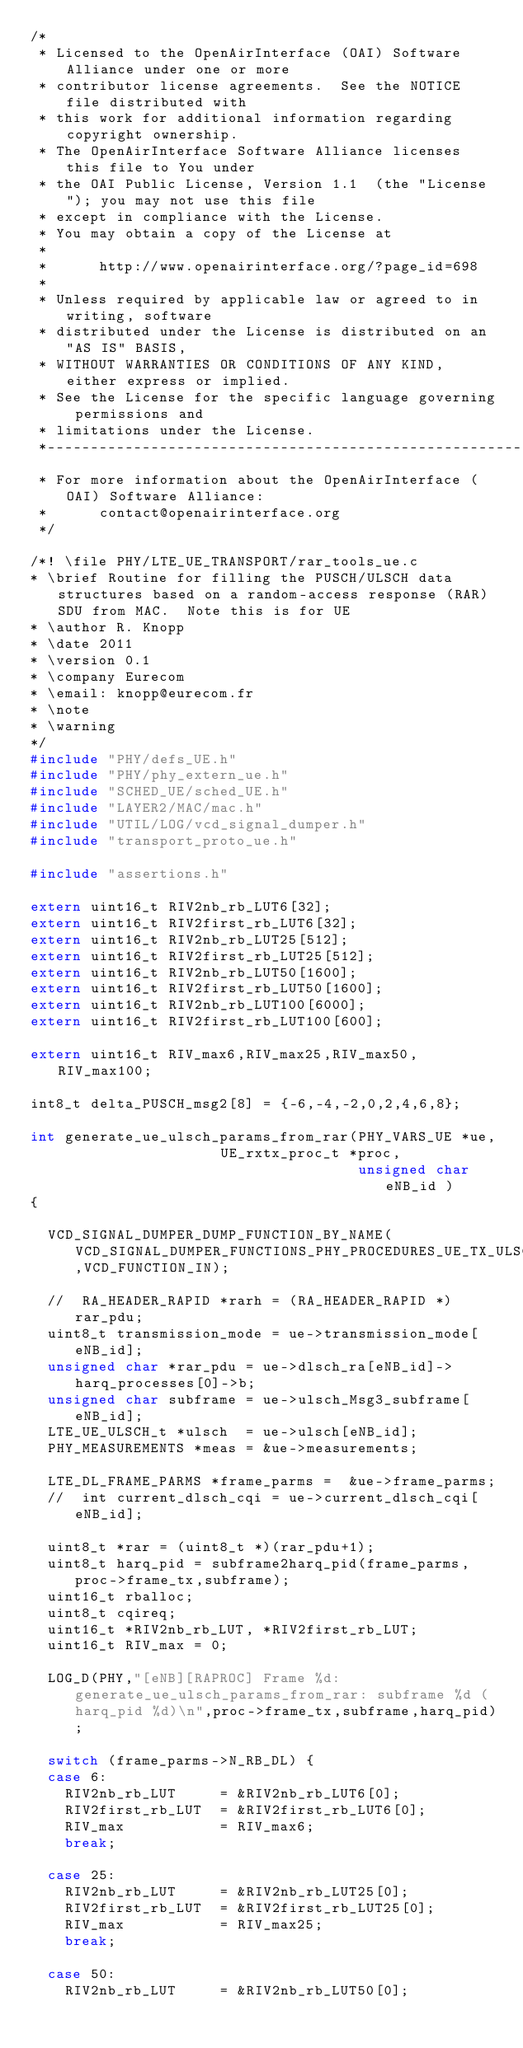<code> <loc_0><loc_0><loc_500><loc_500><_C_>/*
 * Licensed to the OpenAirInterface (OAI) Software Alliance under one or more
 * contributor license agreements.  See the NOTICE file distributed with
 * this work for additional information regarding copyright ownership.
 * The OpenAirInterface Software Alliance licenses this file to You under
 * the OAI Public License, Version 1.1  (the "License"); you may not use this file
 * except in compliance with the License.
 * You may obtain a copy of the License at
 *
 *      http://www.openairinterface.org/?page_id=698
 *
 * Unless required by applicable law or agreed to in writing, software
 * distributed under the License is distributed on an "AS IS" BASIS,
 * WITHOUT WARRANTIES OR CONDITIONS OF ANY KIND, either express or implied.
 * See the License for the specific language governing permissions and
 * limitations under the License.
 *-------------------------------------------------------------------------------
 * For more information about the OpenAirInterface (OAI) Software Alliance:
 *      contact@openairinterface.org
 */

/*! \file PHY/LTE_UE_TRANSPORT/rar_tools_ue.c
* \brief Routine for filling the PUSCH/ULSCH data structures based on a random-access response (RAR) SDU from MAC.  Note this is for UE 
* \author R. Knopp
* \date 2011
* \version 0.1
* \company Eurecom
* \email: knopp@eurecom.fr
* \note
* \warning
*/
#include "PHY/defs_UE.h"
#include "PHY/phy_extern_ue.h"
#include "SCHED_UE/sched_UE.h"
#include "LAYER2/MAC/mac.h"
#include "UTIL/LOG/vcd_signal_dumper.h"
#include "transport_proto_ue.h"

#include "assertions.h"

extern uint16_t RIV2nb_rb_LUT6[32];
extern uint16_t RIV2first_rb_LUT6[32];
extern uint16_t RIV2nb_rb_LUT25[512];
extern uint16_t RIV2first_rb_LUT25[512];
extern uint16_t RIV2nb_rb_LUT50[1600];
extern uint16_t RIV2first_rb_LUT50[1600];
extern uint16_t RIV2nb_rb_LUT100[6000];
extern uint16_t RIV2first_rb_LUT100[600];

extern uint16_t RIV_max6,RIV_max25,RIV_max50,RIV_max100;

int8_t delta_PUSCH_msg2[8] = {-6,-4,-2,0,2,4,6,8};

int generate_ue_ulsch_params_from_rar(PHY_VARS_UE *ue,
				      UE_rxtx_proc_t *proc,
                                      unsigned char eNB_id )
{

  VCD_SIGNAL_DUMPER_DUMP_FUNCTION_BY_NAME(VCD_SIGNAL_DUMPER_FUNCTIONS_PHY_PROCEDURES_UE_TX_ULSCH_RAR,VCD_FUNCTION_IN);

  //  RA_HEADER_RAPID *rarh = (RA_HEADER_RAPID *)rar_pdu;
  uint8_t transmission_mode = ue->transmission_mode[eNB_id];
  unsigned char *rar_pdu = ue->dlsch_ra[eNB_id]->harq_processes[0]->b;
  unsigned char subframe = ue->ulsch_Msg3_subframe[eNB_id];
  LTE_UE_ULSCH_t *ulsch  = ue->ulsch[eNB_id];
  PHY_MEASUREMENTS *meas = &ue->measurements;

  LTE_DL_FRAME_PARMS *frame_parms =  &ue->frame_parms;
  //  int current_dlsch_cqi = ue->current_dlsch_cqi[eNB_id];

  uint8_t *rar = (uint8_t *)(rar_pdu+1);
  uint8_t harq_pid = subframe2harq_pid(frame_parms,proc->frame_tx,subframe);
  uint16_t rballoc;
  uint8_t cqireq;
  uint16_t *RIV2nb_rb_LUT, *RIV2first_rb_LUT;
  uint16_t RIV_max = 0;

  LOG_D(PHY,"[eNB][RAPROC] Frame %d: generate_ue_ulsch_params_from_rar: subframe %d (harq_pid %d)\n",proc->frame_tx,subframe,harq_pid);

  switch (frame_parms->N_RB_DL) {
  case 6:
    RIV2nb_rb_LUT     = &RIV2nb_rb_LUT6[0];
    RIV2first_rb_LUT  = &RIV2first_rb_LUT6[0];
    RIV_max           = RIV_max6;
    break;

  case 25:
    RIV2nb_rb_LUT     = &RIV2nb_rb_LUT25[0];
    RIV2first_rb_LUT  = &RIV2first_rb_LUT25[0];
    RIV_max           = RIV_max25;
    break;

  case 50:
    RIV2nb_rb_LUT     = &RIV2nb_rb_LUT50[0];</code> 